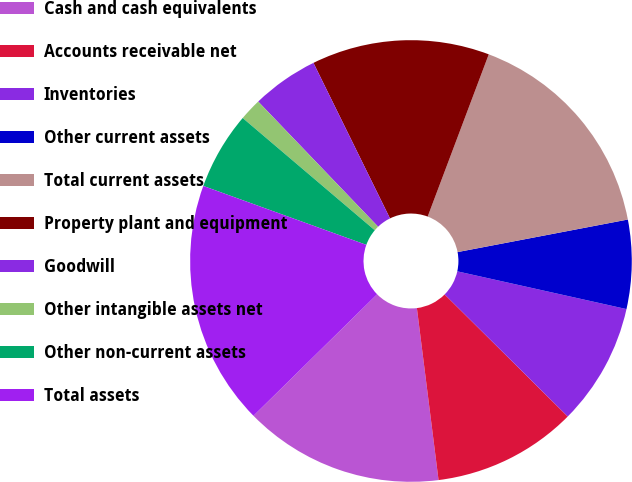<chart> <loc_0><loc_0><loc_500><loc_500><pie_chart><fcel>Cash and cash equivalents<fcel>Accounts receivable net<fcel>Inventories<fcel>Other current assets<fcel>Total current assets<fcel>Property plant and equipment<fcel>Goodwill<fcel>Other intangible assets net<fcel>Other non-current assets<fcel>Total assets<nl><fcel>14.63%<fcel>10.57%<fcel>8.94%<fcel>6.5%<fcel>16.26%<fcel>13.01%<fcel>4.88%<fcel>1.63%<fcel>5.69%<fcel>17.88%<nl></chart> 